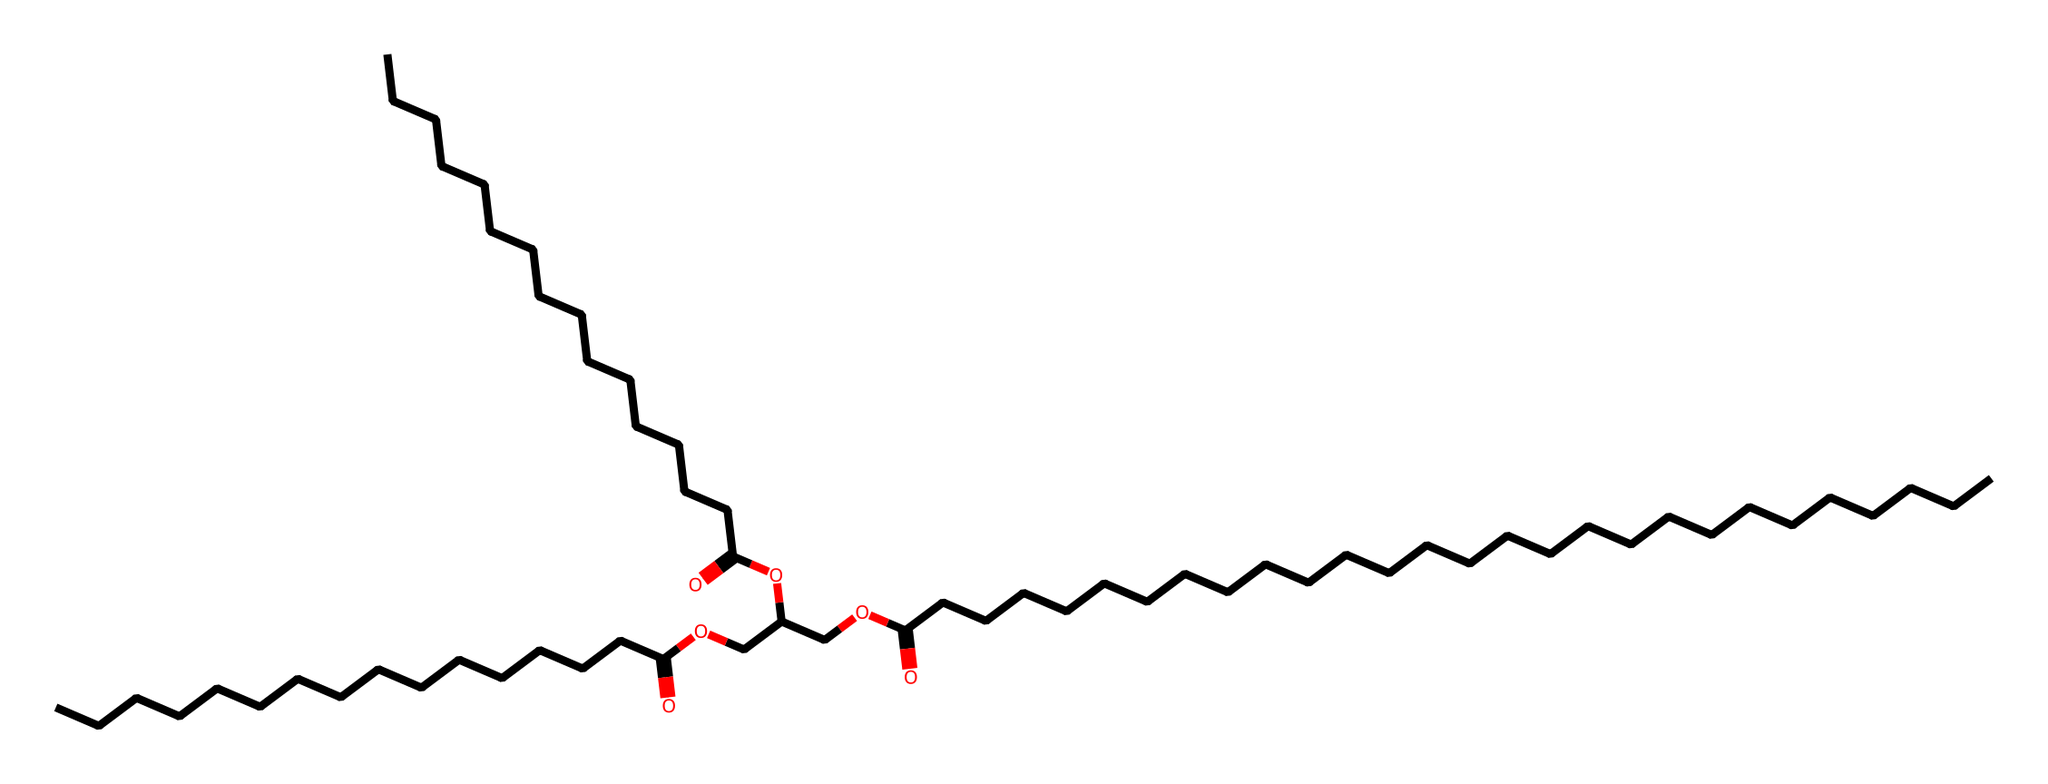What is the main functional group present in this chemical? This chemical contains ester linkages, indicated by the -COO- (carbonyl and ether) groups. Esters are characterized by having this functional group, which is present in the structure.
Answer: ester How many carbon atoms are in the longest carbon chain? The longest carbon chain can be traced from the start to the end of the molecule, counting a total of 22 carbon atoms in the chain.
Answer: 22 What type of reaction is used to form the esters present in this chemical? The formation of these esters typically involves a condensation reaction, where carboxylic acids react with alcohols, releasing water. This type of reaction is standard for ester synthesis and is observed in this molecule.
Answer: condensation What is the total number of oxygen atoms in this chemical? The structure contains three ester functional groups, each contributing two oxygen atoms, leading to a total of 6 oxygen atoms present in the entire molecule.
Answer: 6 What property makes this chemical suitable for natural candles? The presence of long carbon chains in this ester structure contributes to its properties, such as a higher melting point and a waxy texture, which make it suitable for candle making.
Answer: waxy How many ester linkages are present in this chemical? By examining the structure, one can identify three distinct ester linkages, characterized by the -COO- group connections. Counting these will confirm that there are three esters.
Answer: 3 